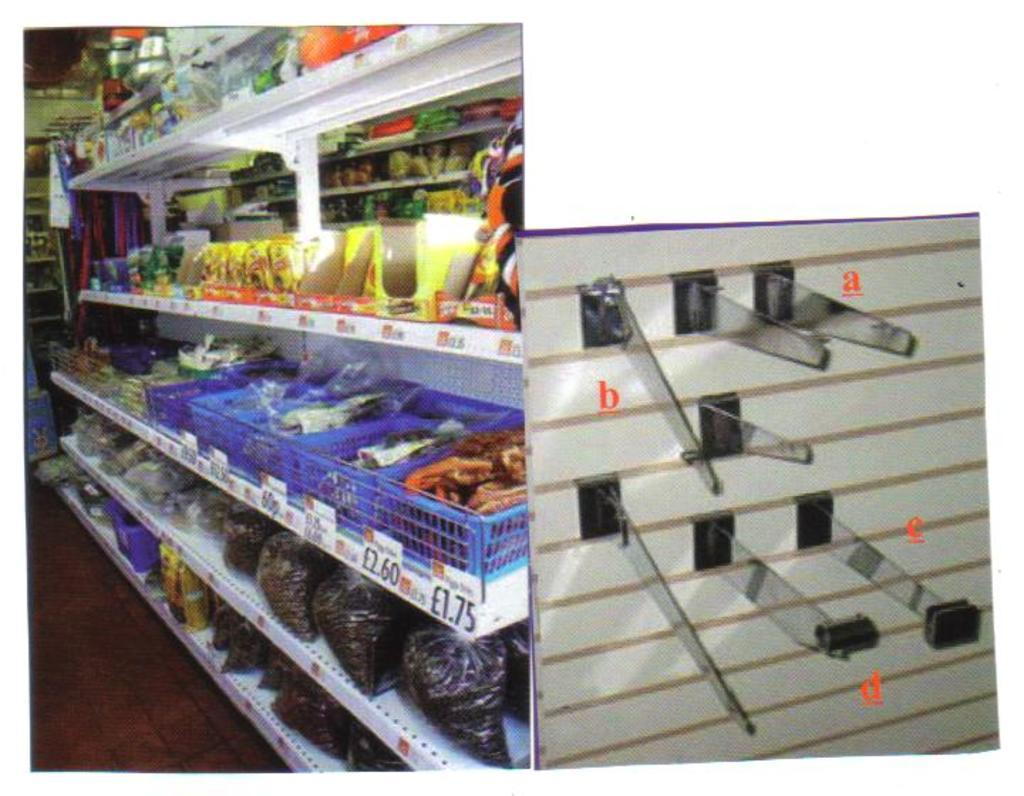<image>
Share a concise interpretation of the image provided. A grocery store has many price labels, one of which is £1.75 